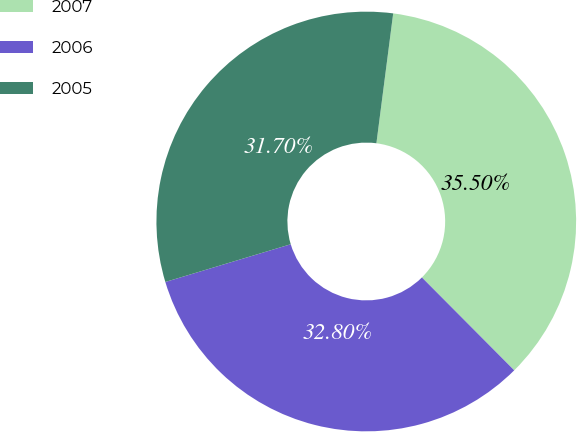Convert chart. <chart><loc_0><loc_0><loc_500><loc_500><pie_chart><fcel>2007<fcel>2006<fcel>2005<nl><fcel>35.5%<fcel>32.8%<fcel>31.7%<nl></chart> 